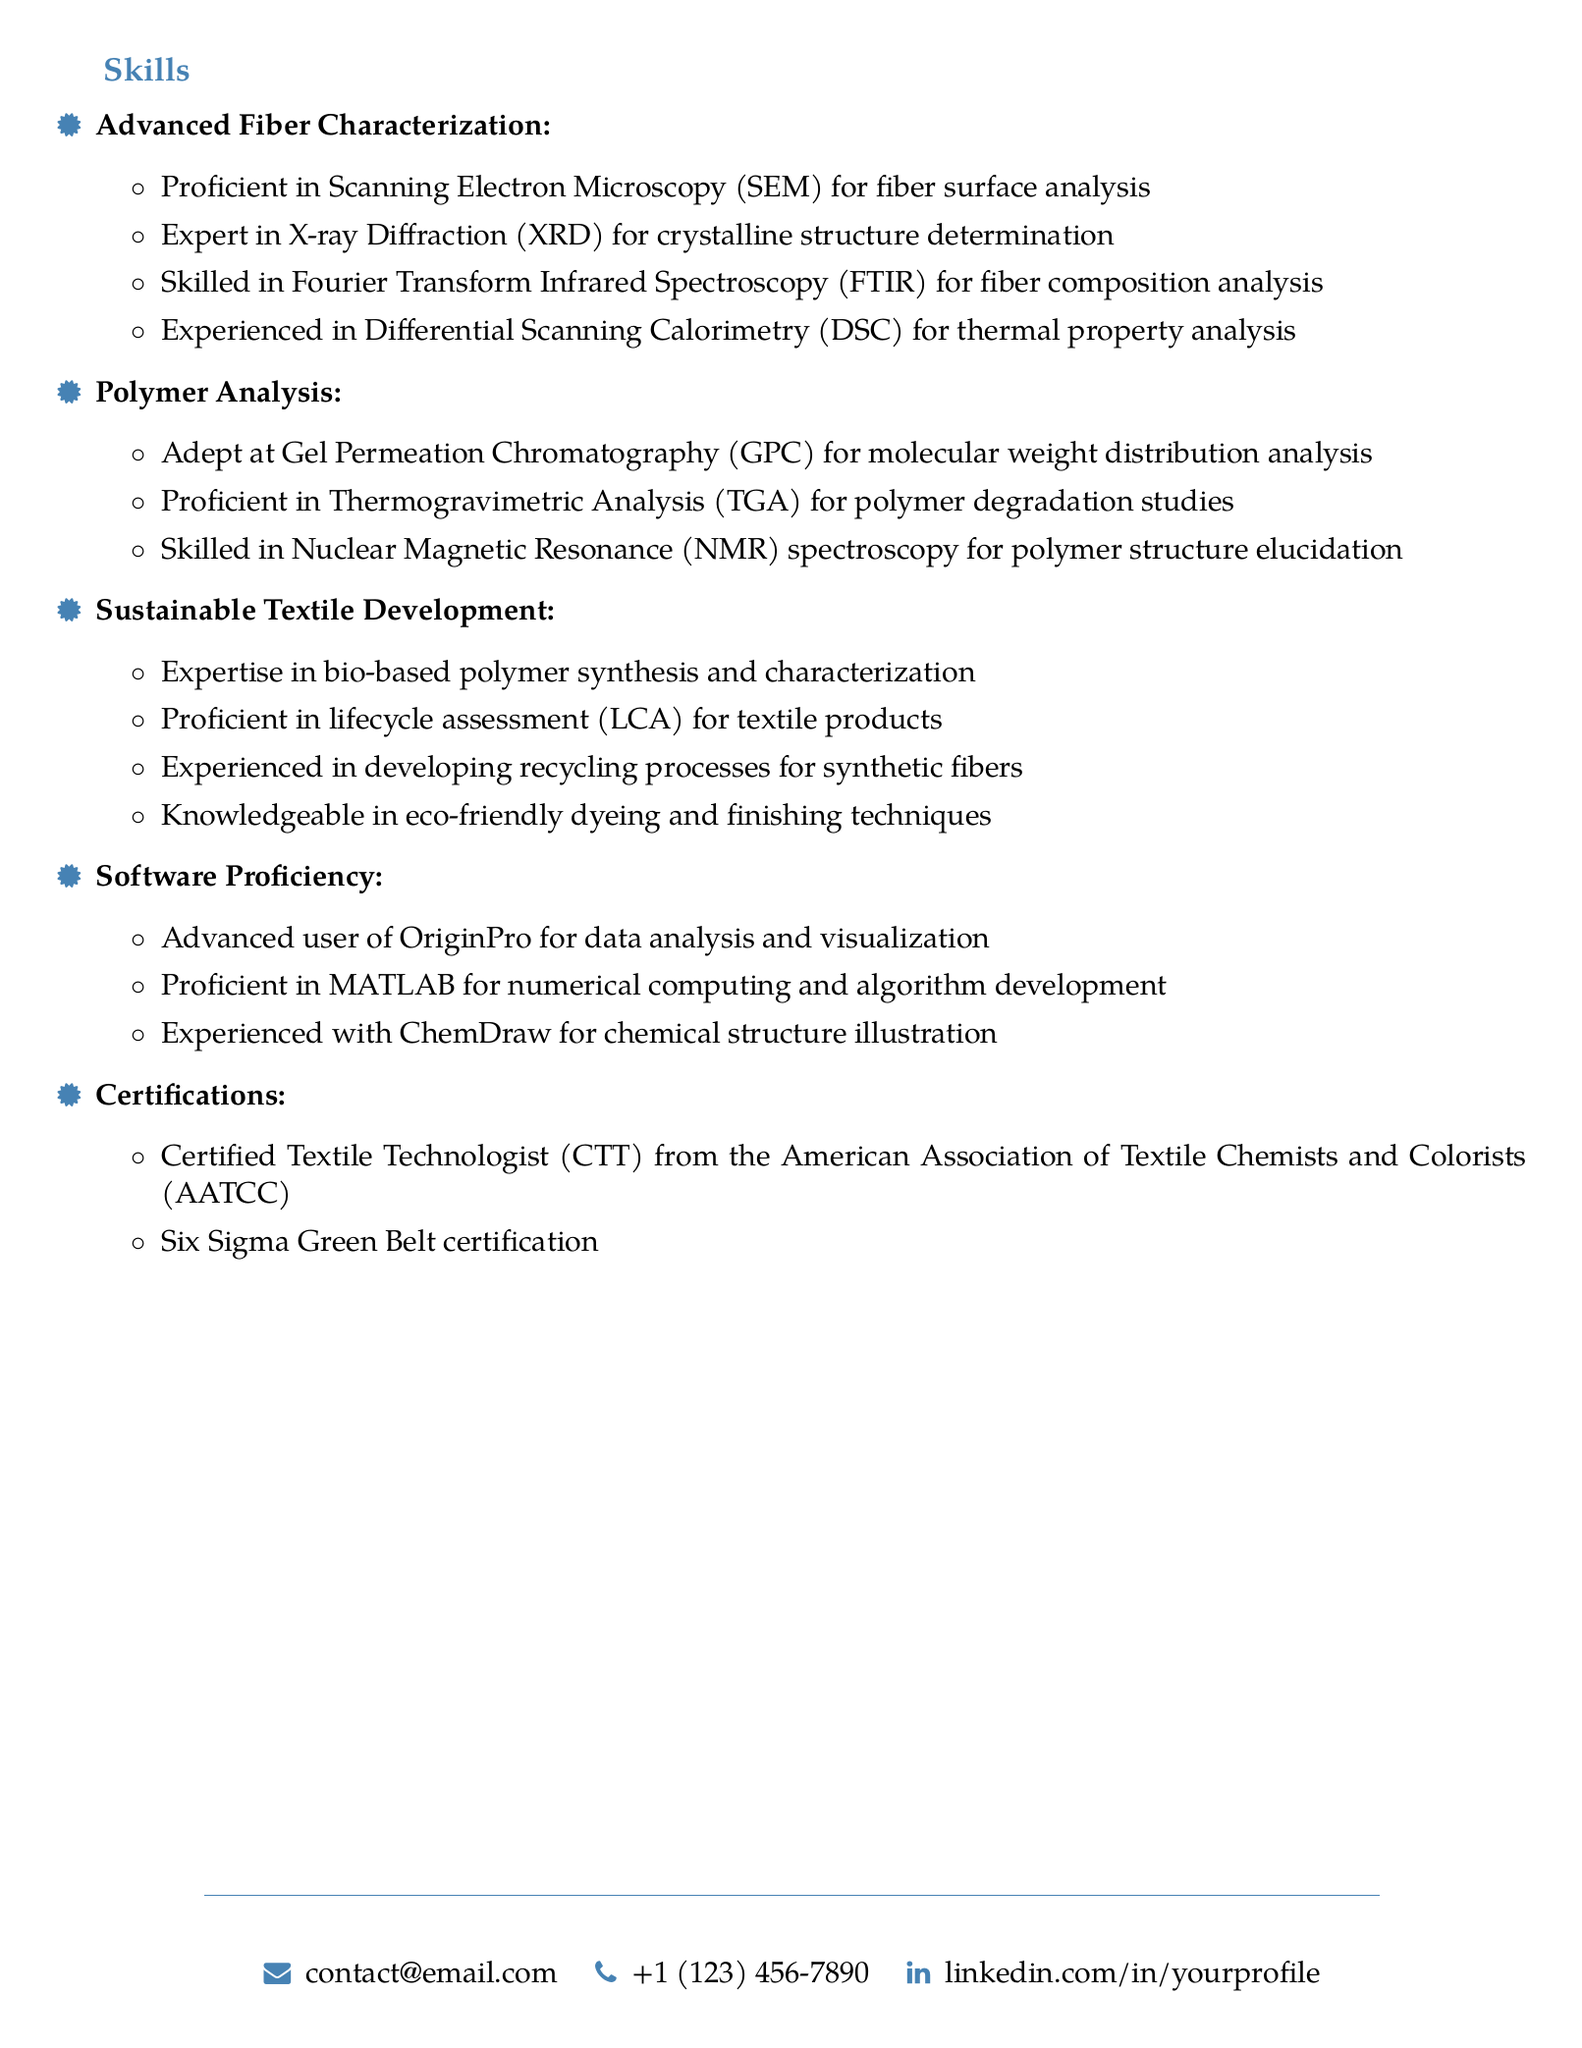What is the primary focus of the skills section? The skills section highlights the individual's expertise in advanced fiber characterization, polymer analysis, and sustainable textile development.
Answer: Fiber science How many techniques are listed under advanced fiber characterization? The document outlines four specific techniques under advanced fiber characterization.
Answer: Four What certification is obtained from the AATCC? The document mentions a specific certification related to textile technology from an association.
Answer: Certified Textile Technologist Which software is listed as advanced user? The document specifies one software that the individual is proficient in data analysis and visualization.
Answer: OriginPro What does the individual have experience in regarding textile products? The sustainable textile development section indicates that the individual has skills related to assessing environmental impacts of textile products.
Answer: Lifecycle assessment Which polymer analysis technique is used for molecular weight distribution? The document names a specific technique utilized to analyze molecular weight distribution.
Answer: Gel Permeation Chromatography What is one technique mentioned for thermal property analysis? The skills section includes a specific technique used to analyze thermal properties of fibers.
Answer: Differential Scanning Calorimetry How many certifications are listed in the skills section? There are two certifications mentioned in the document under the certifications subsection.
Answer: Two What does the individual have expertise in regarding dyeing? The skills section highlights knowledge in a specific technique related to environmentally friendly dyeing methods.
Answer: Eco-friendly dyeing techniques 